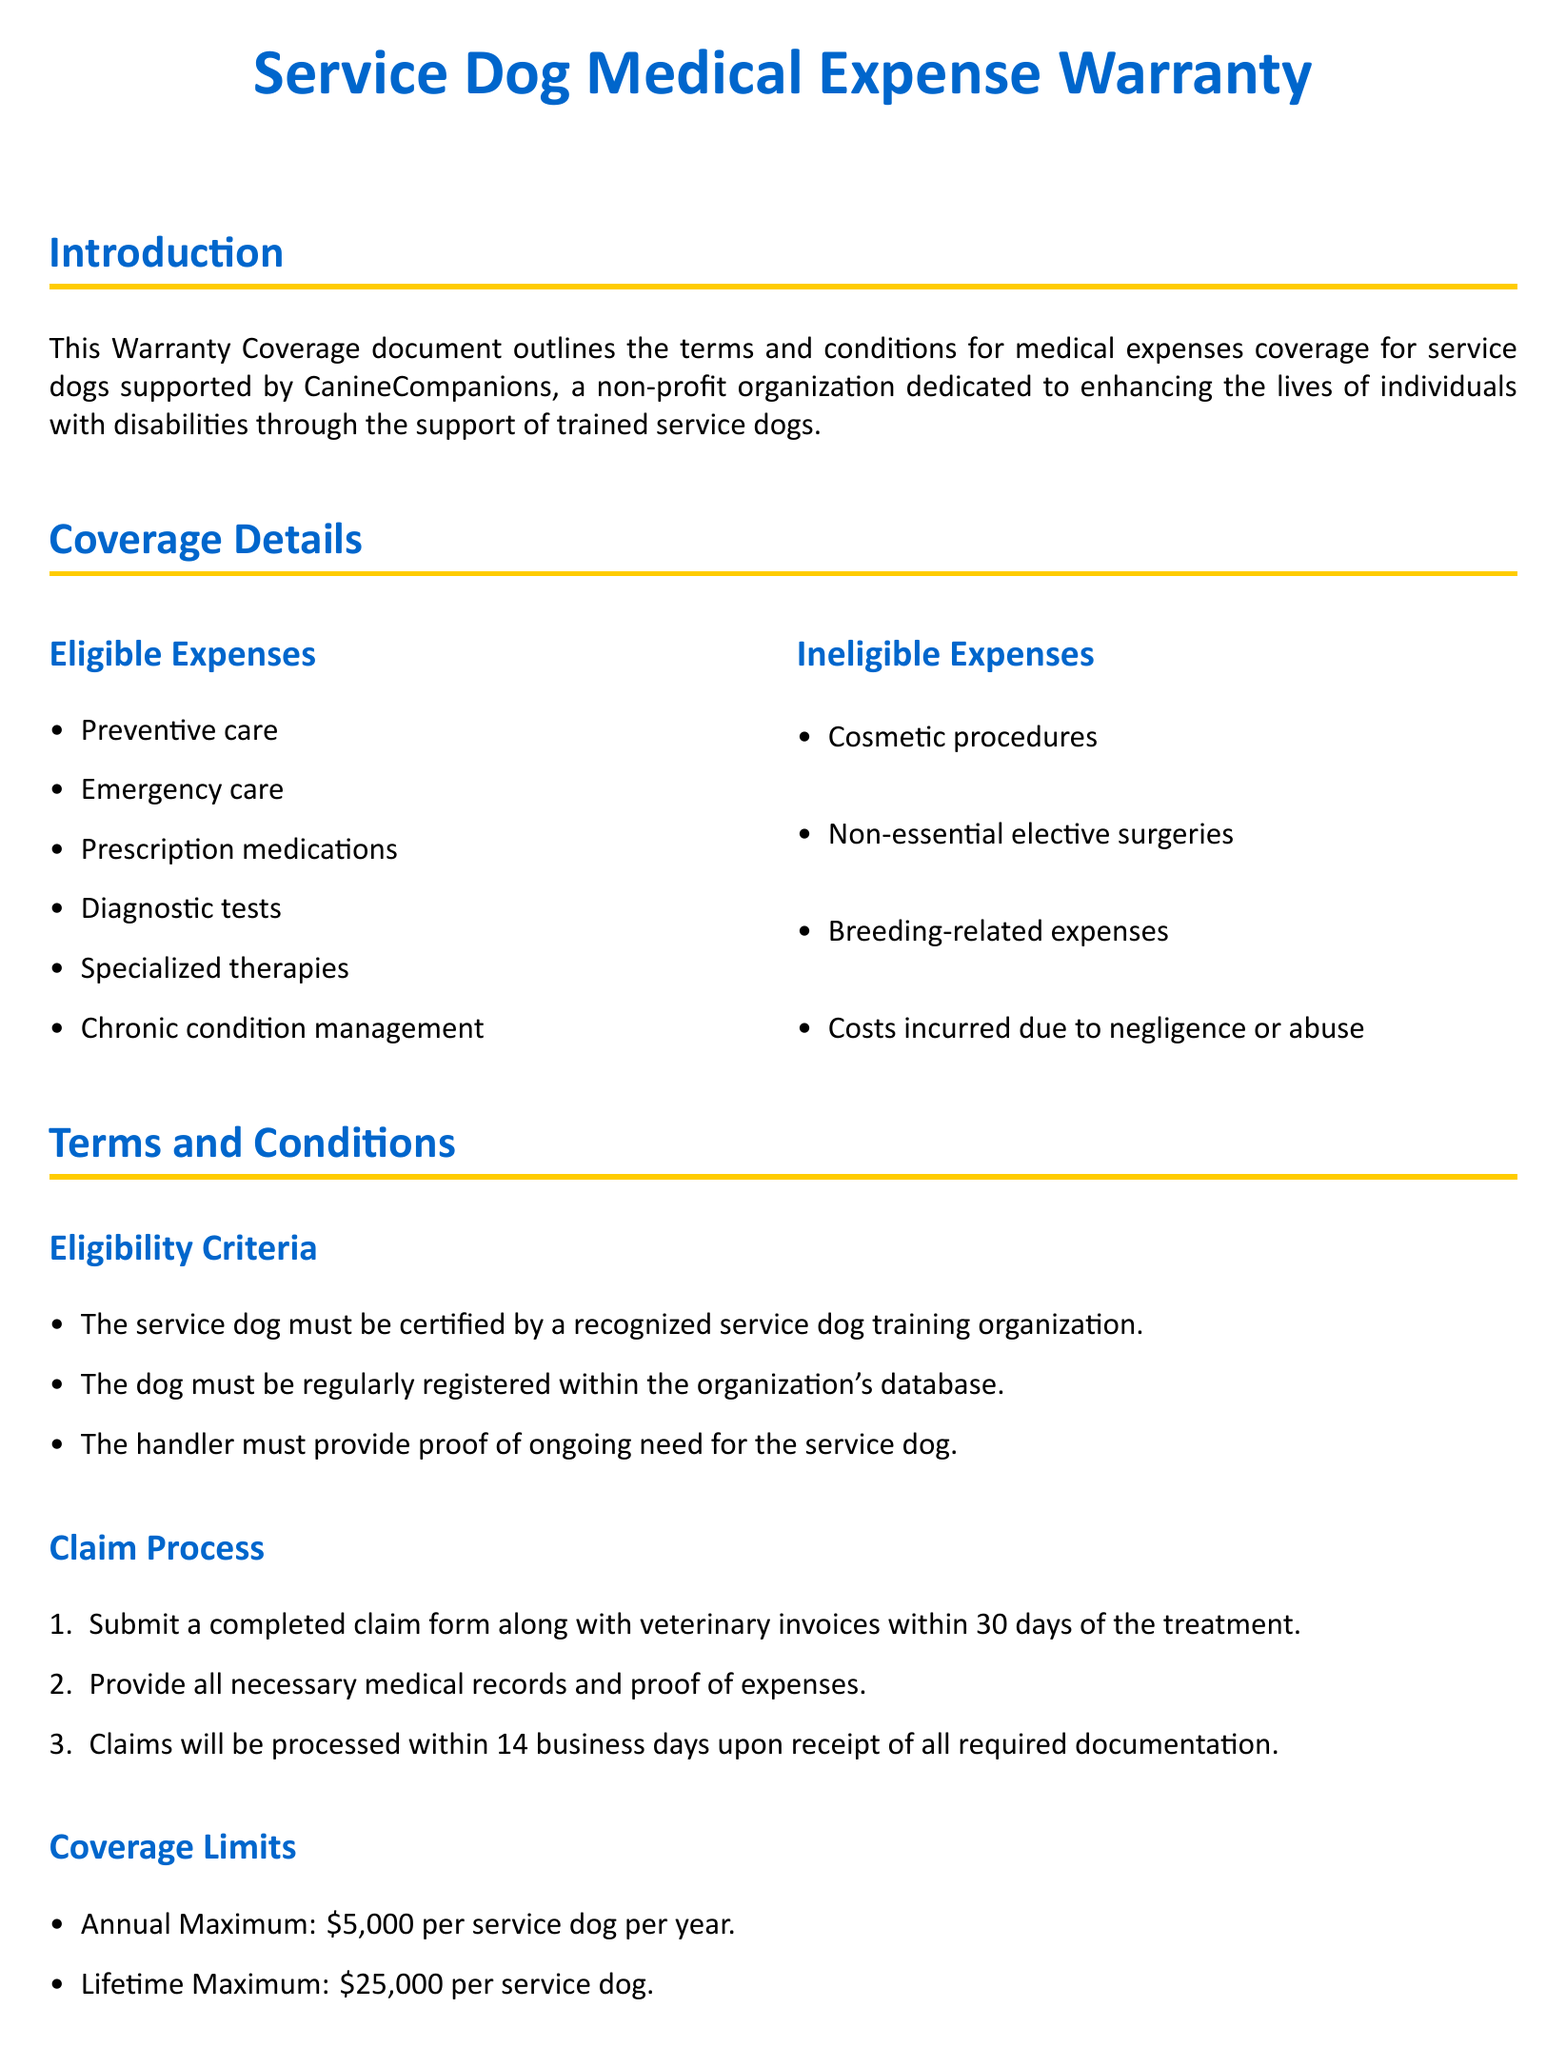what is the annual maximum coverage limit? The document states the annual maximum coverage limit is specified under coverage limits, which is $5,000 per service dog per year.
Answer: $5,000 what is the lifetime maximum coverage limit? The document indicates that the lifetime maximum coverage limit is detailed in the coverage limits section as $25,000 per service dog.
Answer: $25,000 what types of expenses are eligible for coverage? The eligible expenses are listed in the coverage details and include preventive care, emergency care, and prescription medications.
Answer: Preventive care, emergency care, prescription medications what must be submitted to initiate a claim? The claim process outlines that a completed claim form must be submitted along with veterinary invoices and necessary medical records.
Answer: Completed claim form and veterinary invoices how long will claims be processed? The document specifies that claims will be processed within 14 business days upon receipt of all required documentation.
Answer: 14 business days what types of expenses are ineligible for coverage? The ineligible expenses are outlined in the coverage details and include cosmetic procedures and breeding-related expenses.
Answer: Cosmetic procedures, breeding-related expenses what is a requirement for the service dog’s eligibility? The eligibility criteria mention that the service dog must be certified by a recognized service dog training organization.
Answer: Certified by a recognized service dog training organization which organization is this warranty document associated with? The introduction states that this warranty coverage document is associated with CanineCompanions, a non-profit organization.
Answer: CanineCompanions what are the hours of customer service? The contact information section provides the customer service hours, which are Monday to Friday, 9 AM - 5 PM EST.
Answer: Monday to Friday, 9 AM - 5 PM EST 